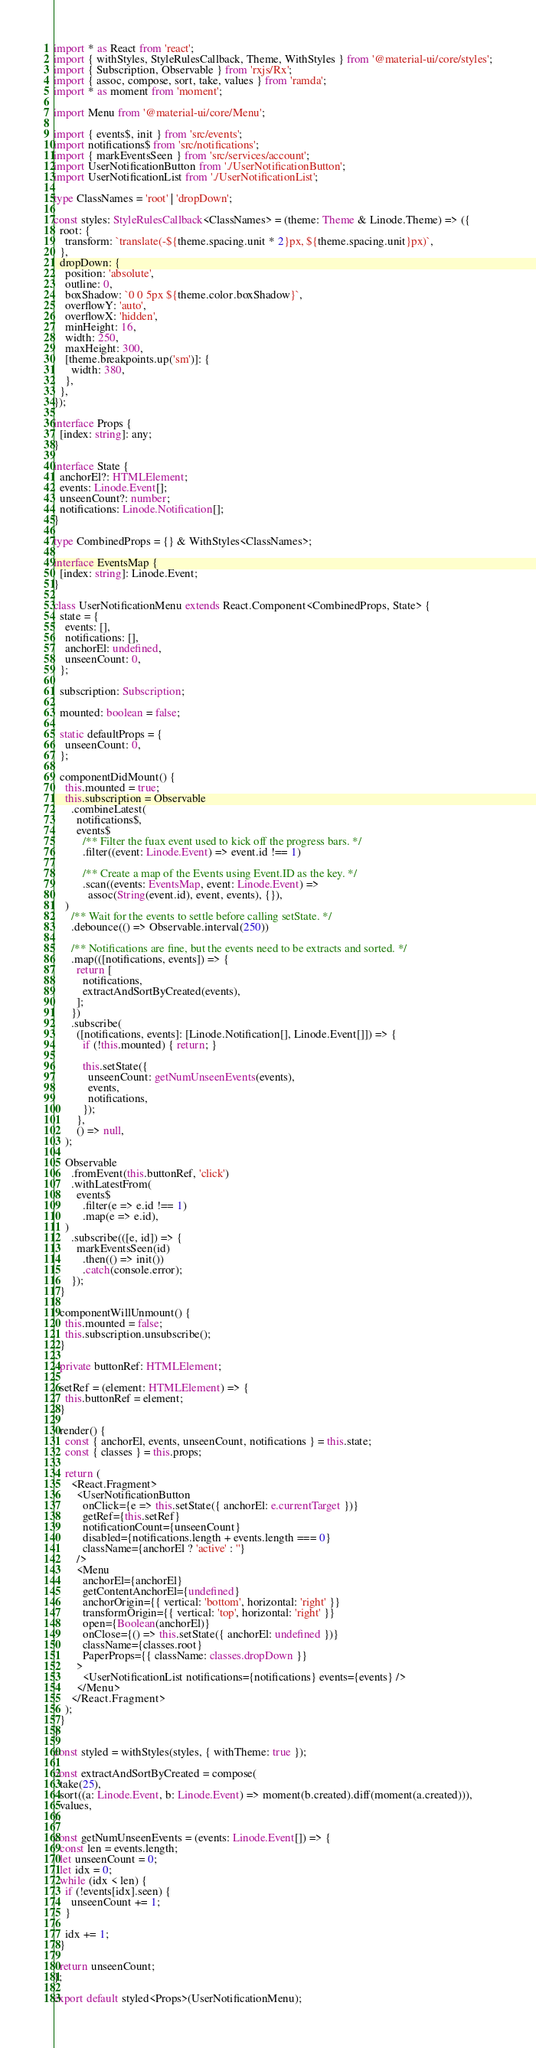<code> <loc_0><loc_0><loc_500><loc_500><_TypeScript_>import * as React from 'react';
import { withStyles, StyleRulesCallback, Theme, WithStyles } from '@material-ui/core/styles';
import { Subscription, Observable } from 'rxjs/Rx';
import { assoc, compose, sort, take, values } from 'ramda';
import * as moment from 'moment';

import Menu from '@material-ui/core/Menu';

import { events$, init } from 'src/events';
import notifications$ from 'src/notifications';
import { markEventsSeen } from 'src/services/account';
import UserNotificationButton from './UserNotificationButton';
import UserNotificationList from './UserNotificationList';

type ClassNames = 'root' | 'dropDown';

const styles: StyleRulesCallback<ClassNames> = (theme: Theme & Linode.Theme) => ({
  root: {
    transform: `translate(-${theme.spacing.unit * 2}px, ${theme.spacing.unit}px)`,
  },
  dropDown: {
    position: 'absolute',
    outline: 0,
    boxShadow: `0 0 5px ${theme.color.boxShadow}`,
    overflowY: 'auto',
    overflowX: 'hidden',
    minHeight: 16,
    width: 250,
    maxHeight: 300,
    [theme.breakpoints.up('sm')]: {
      width: 380,
    },
  },
});

interface Props {
  [index: string]: any;
}

interface State {
  anchorEl?: HTMLElement;
  events: Linode.Event[];
  unseenCount?: number;
  notifications: Linode.Notification[];
}

type CombinedProps = {} & WithStyles<ClassNames>;

interface EventsMap {
  [index: string]: Linode.Event;
}

class UserNotificationMenu extends React.Component<CombinedProps, State> {
  state = {
    events: [],
    notifications: [],
    anchorEl: undefined,
    unseenCount: 0,
  };

  subscription: Subscription;

  mounted: boolean = false;

  static defaultProps = {
    unseenCount: 0,
  };

  componentDidMount() {
    this.mounted = true;
    this.subscription = Observable
      .combineLatest(
        notifications$,
        events$
          /** Filter the fuax event used to kick off the progress bars. */
          .filter((event: Linode.Event) => event.id !== 1)

          /** Create a map of the Events using Event.ID as the key. */
          .scan((events: EventsMap, event: Linode.Event) =>
            assoc(String(event.id), event, events), {}),
    )
      /** Wait for the events to settle before calling setState. */
      .debounce(() => Observable.interval(250))

      /** Notifications are fine, but the events need to be extracts and sorted. */
      .map(([notifications, events]) => {
        return [
          notifications,
          extractAndSortByCreated(events),
        ];
      })
      .subscribe(
        ([notifications, events]: [Linode.Notification[], Linode.Event[]]) => {
          if (!this.mounted) { return; }

          this.setState({
            unseenCount: getNumUnseenEvents(events),
            events,
            notifications,
          });
        },
        () => null,
    );

    Observable
      .fromEvent(this.buttonRef, 'click')
      .withLatestFrom(
        events$
          .filter(e => e.id !== 1)
          .map(e => e.id),
    )
      .subscribe(([e, id]) => {
        markEventsSeen(id)
          .then(() => init())
          .catch(console.error);
      });
  }

  componentWillUnmount() {
    this.mounted = false;
    this.subscription.unsubscribe();
  }

  private buttonRef: HTMLElement;

  setRef = (element: HTMLElement) => {
    this.buttonRef = element;
  }

  render() {
    const { anchorEl, events, unseenCount, notifications } = this.state;
    const { classes } = this.props;

    return (
      <React.Fragment>
        <UserNotificationButton
          onClick={e => this.setState({ anchorEl: e.currentTarget })}
          getRef={this.setRef}
          notificationCount={unseenCount}
          disabled={notifications.length + events.length === 0}
          className={anchorEl ? 'active' : ''}
        />
        <Menu
          anchorEl={anchorEl}
          getContentAnchorEl={undefined}
          anchorOrigin={{ vertical: 'bottom', horizontal: 'right' }}
          transformOrigin={{ vertical: 'top', horizontal: 'right' }}
          open={Boolean(anchorEl)}
          onClose={() => this.setState({ anchorEl: undefined })}
          className={classes.root}
          PaperProps={{ className: classes.dropDown }}
        >
          <UserNotificationList notifications={notifications} events={events} />
        </Menu>
      </React.Fragment>
    );
  }
}

const styled = withStyles(styles, { withTheme: true });

const extractAndSortByCreated = compose(
  take(25),
  sort((a: Linode.Event, b: Linode.Event) => moment(b.created).diff(moment(a.created))),
  values,
);

const getNumUnseenEvents = (events: Linode.Event[]) => {
  const len = events.length;
  let unseenCount = 0;
  let idx = 0;
  while (idx < len) {
    if (!events[idx].seen) {
      unseenCount += 1;
    }

    idx += 1;
  }

  return unseenCount;
};

export default styled<Props>(UserNotificationMenu);
</code> 